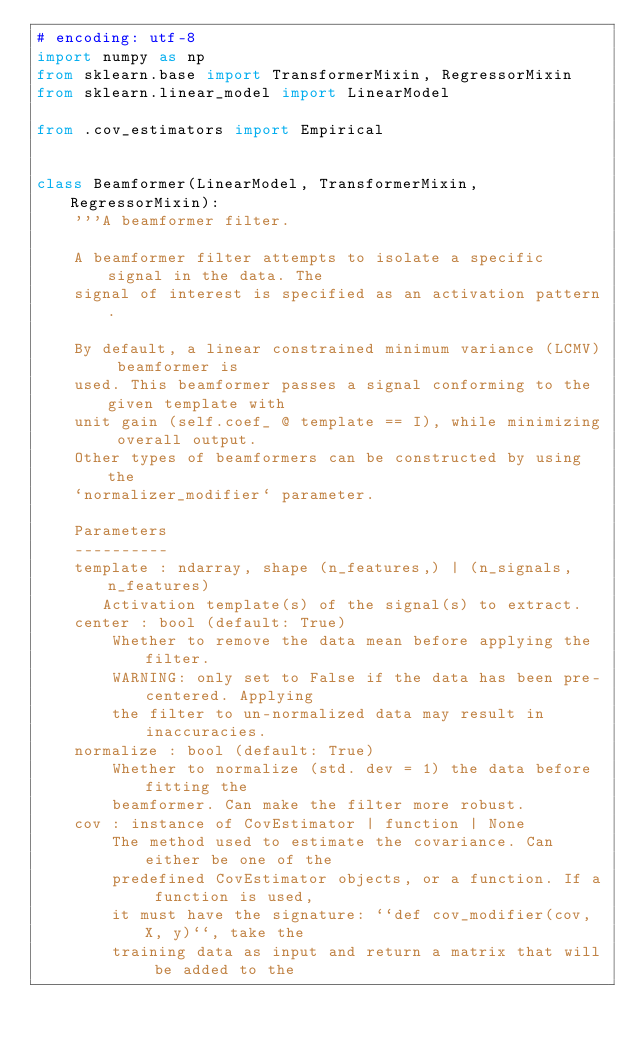<code> <loc_0><loc_0><loc_500><loc_500><_Python_># encoding: utf-8
import numpy as np
from sklearn.base import TransformerMixin, RegressorMixin
from sklearn.linear_model import LinearModel

from .cov_estimators import Empirical


class Beamformer(LinearModel, TransformerMixin, RegressorMixin):
    '''A beamformer filter.

    A beamformer filter attempts to isolate a specific signal in the data. The
    signal of interest is specified as an activation pattern.

    By default, a linear constrained minimum variance (LCMV) beamformer is
    used. This beamformer passes a signal conforming to the given template with
    unit gain (self.coef_ @ template == I), while minimizing overall output.
    Other types of beamformers can be constructed by using the
    `normalizer_modifier` parameter.

    Parameters
    ----------
    template : ndarray, shape (n_features,) | (n_signals, n_features)
       Activation template(s) of the signal(s) to extract.
    center : bool (default: True)
        Whether to remove the data mean before applying the filter.
        WARNING: only set to False if the data has been pre-centered. Applying
        the filter to un-normalized data may result in inaccuracies.
    normalize : bool (default: True)
        Whether to normalize (std. dev = 1) the data before fitting the
        beamformer. Can make the filter more robust.
    cov : instance of CovEstimator | function | None
        The method used to estimate the covariance. Can either be one of the
        predefined CovEstimator objects, or a function. If a function is used,
        it must have the signature: ``def cov_modifier(cov, X, y)``, take the
        training data as input and return a matrix that will be added to the</code> 